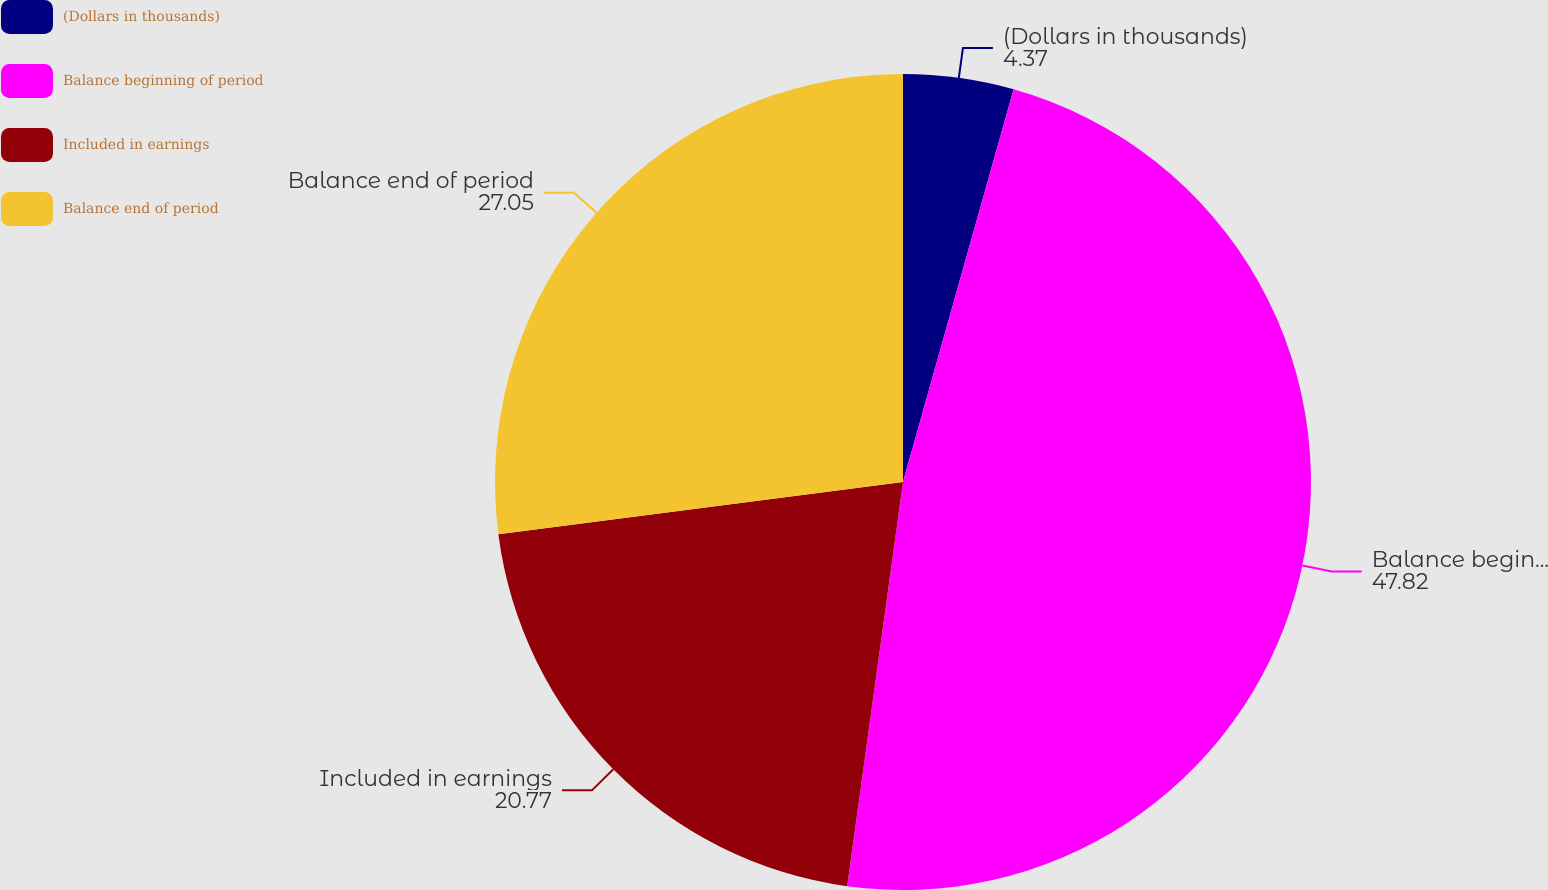Convert chart. <chart><loc_0><loc_0><loc_500><loc_500><pie_chart><fcel>(Dollars in thousands)<fcel>Balance beginning of period<fcel>Included in earnings<fcel>Balance end of period<nl><fcel>4.37%<fcel>47.82%<fcel>20.77%<fcel>27.05%<nl></chart> 